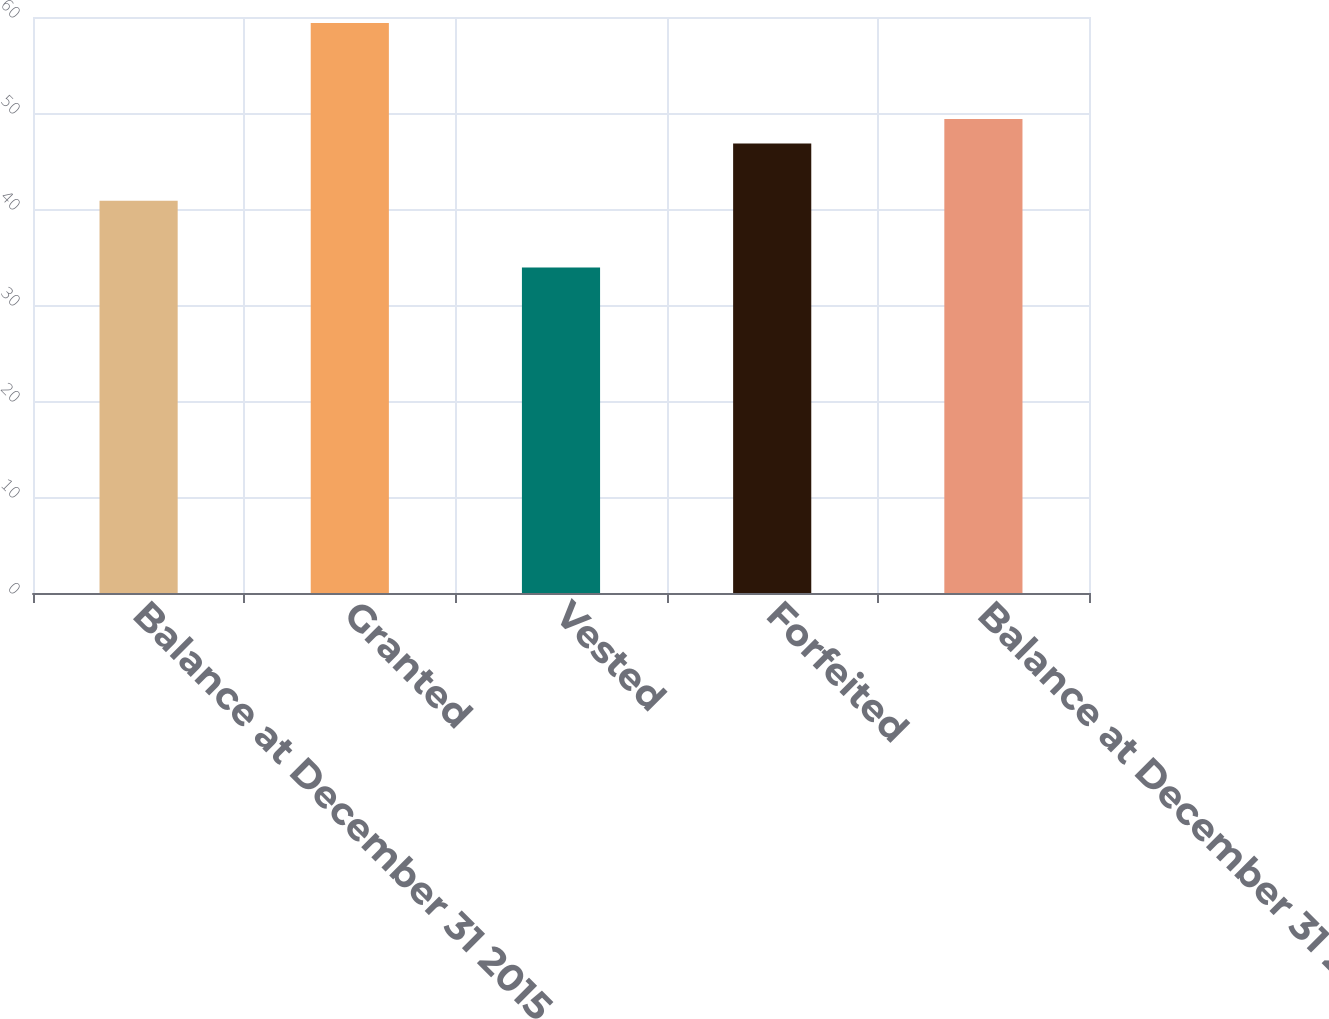Convert chart to OTSL. <chart><loc_0><loc_0><loc_500><loc_500><bar_chart><fcel>Balance at December 31 2015<fcel>Granted<fcel>Vested<fcel>Forfeited<fcel>Balance at December 31 2016<nl><fcel>40.86<fcel>59.38<fcel>33.9<fcel>46.83<fcel>49.38<nl></chart> 